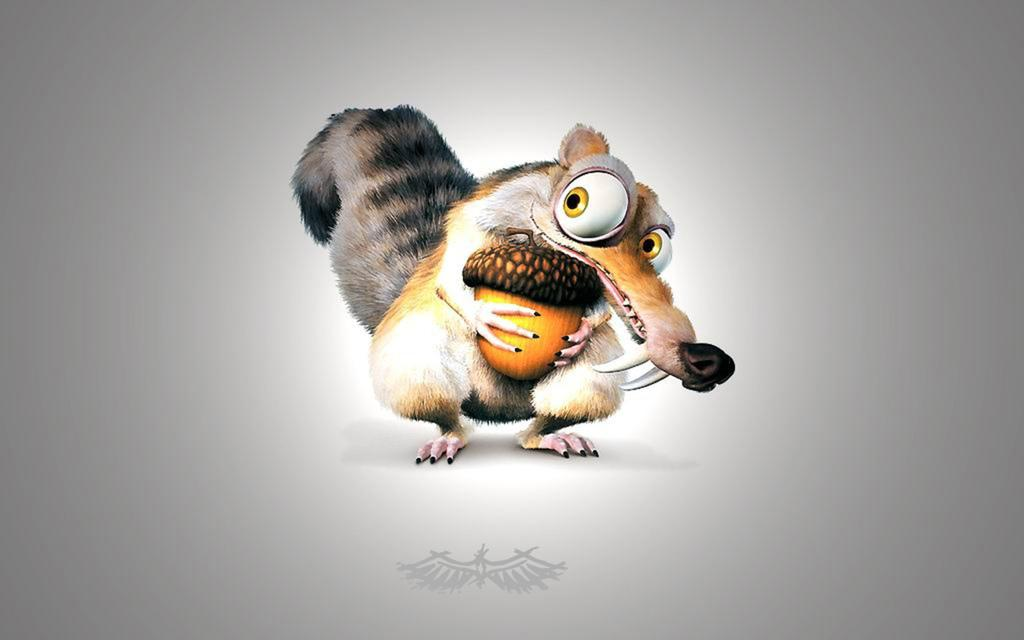What type of image is being described? The image is animated. What can be seen in the animated image? There is an animal in the image. What is the animal doing in the image? The animal is holding a nut in its hand. What is the color of the background in the image? The background of the image is white in color. Can you tell me how many houses are visible in the image? There are no houses visible in the image; it features an animated animal holding a nut. What type of friend is standing next to the animal in the image? There is no friend present in the image; it only features an animated animal holding a nut. 